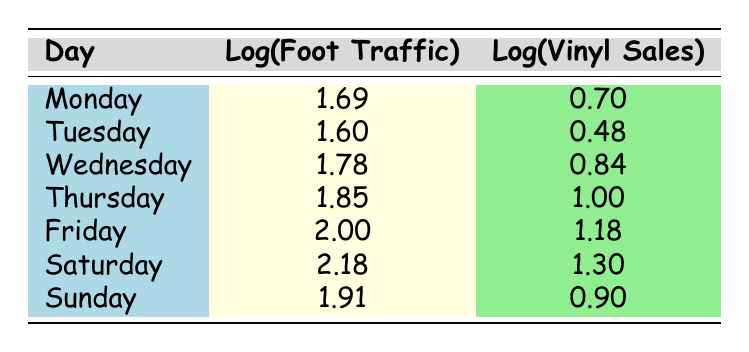What is the logarithmic value of foot traffic on Saturday? The table shows that the log of foot traffic for Saturday is listed directly under the log traffic column. Referring to the table, the value is 2.18.
Answer: 2.18 Which day had the highest vinyl sales based on the logarithmic values? By examining the log sales column, the highest value is found for Saturday, which is 1.30. This indicates that Saturday had the highest log sales.
Answer: Saturday What is the difference between the logarithmic values of foot traffic on Friday and Monday? To find the difference, we subtract the log traffic value for Monday (1.69) from that for Friday (2.00). Therefore, 2.00 - 1.69 = 0.31.
Answer: 0.31 Is the log of vinyl sales on Thursday greater than the log of vinyl sales on Tuesday? Comparing the log sales values, Thursday is 1.00 and Tuesday is 0.48. Since 1.00 > 0.48, the statement is true.
Answer: Yes What day had the lowest foot traffic log value, and what was that value? Looking at the log traffic column, Tuesday has the lowest value at 1.60. Thus, Tuesday is the day with the lowest foot traffic log value.
Answer: Tuesday, 1.60 What is the average log of vinyl sales for the week? To find the average, sum the log sales values (0.70 + 0.48 + 0.84 + 1.00 + 1.18 + 1.30 + 0.90 = 6.40) and divide by 7 (the number of days): 6.40 / 7 = 0.9142857. Rounding to two decimal places gives 0.91.
Answer: 0.91 Is there a linear increase in log foot traffic from Monday to Saturday? Analyzing the log traffic values: they start at 1.69 (Monday) and end at 2.18 (Saturday). Since the values increase every day, particularly with the highest increase from Friday to Saturday, it indicates a steady trend.
Answer: Yes How many more vinyl records were sold on Saturday compared to Tuesday? On Saturday, 20 vinyl records were sold, while on Tuesday only 3 were sold. The difference is calculated as 20 - 3 = 17.
Answer: 17 